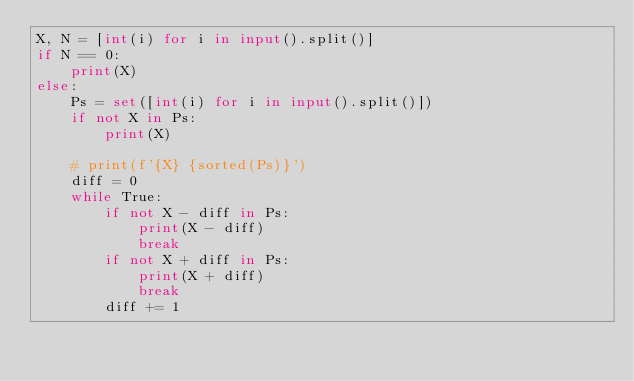Convert code to text. <code><loc_0><loc_0><loc_500><loc_500><_Python_>X, N = [int(i) for i in input().split()]
if N == 0:
    print(X)
else:
    Ps = set([int(i) for i in input().split()])
    if not X in Ps:
        print(X)

    # print(f'{X} {sorted(Ps)}')
    diff = 0
    while True:
        if not X - diff in Ps:
            print(X - diff)
            break
        if not X + diff in Ps:
            print(X + diff)
            break
        diff += 1</code> 